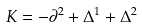<formula> <loc_0><loc_0><loc_500><loc_500>K = - \partial ^ { 2 } + \Delta ^ { 1 } + \Delta ^ { 2 }</formula> 